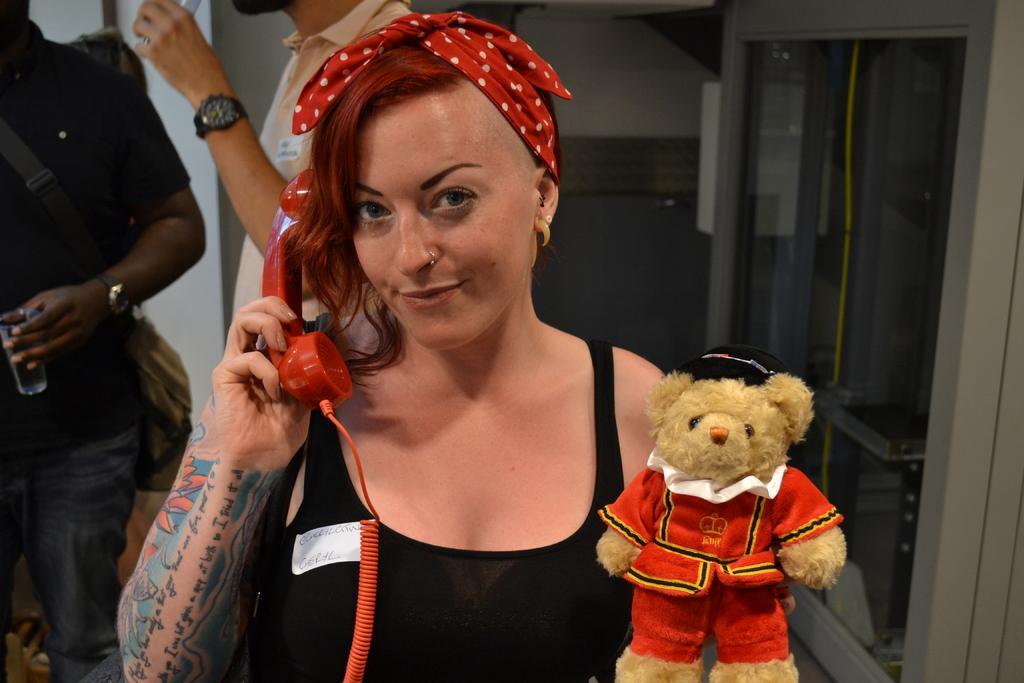What is the person in the foreground of the image holding? The person is holding a telephone receiver in the image. What other object can be seen in the image? There is a toy in the image. Can you describe the people in the background of the image? The two persons in the background are holding glasses. What else is present in the image besides the people and objects mentioned? There are other objects present in the image. What type of lettuce is being used as a stamp in the image? There is no lettuce or stamp present in the image. 